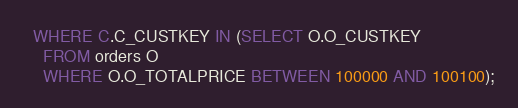<code> <loc_0><loc_0><loc_500><loc_500><_SQL_>  WHERE C.C_CUSTKEY IN (SELECT O.O_CUSTKEY 
	FROM orders O 
	WHERE O.O_TOTALPRICE BETWEEN 100000 AND 100100);
</code> 